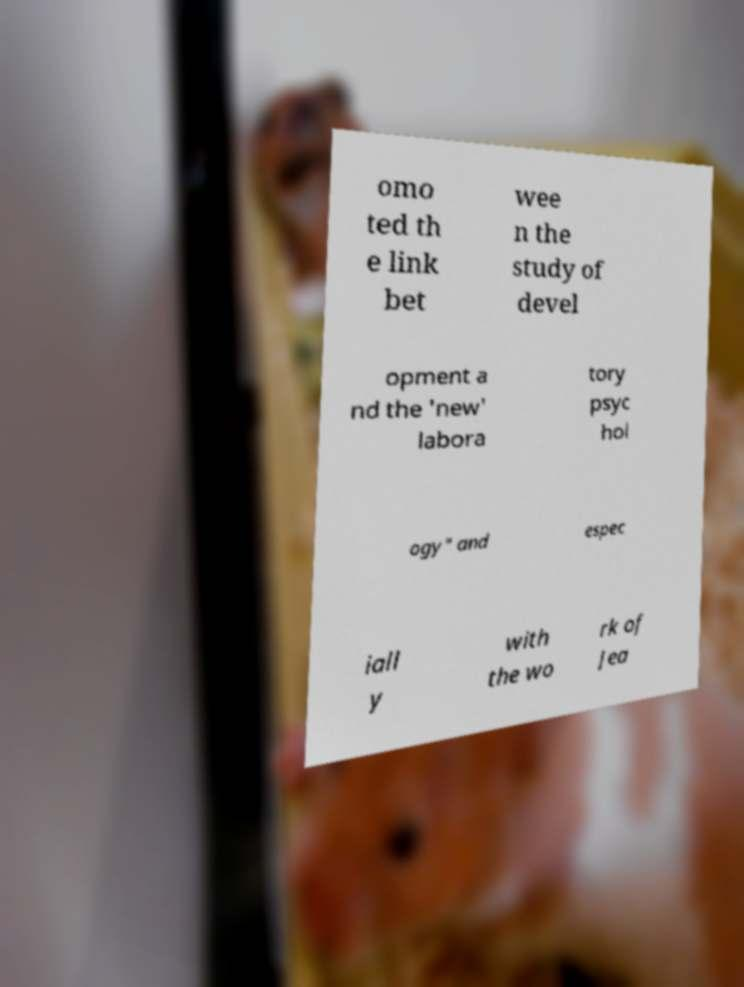What messages or text are displayed in this image? I need them in a readable, typed format. omo ted th e link bet wee n the study of devel opment a nd the 'new' labora tory psyc hol ogy" and espec iall y with the wo rk of Jea 